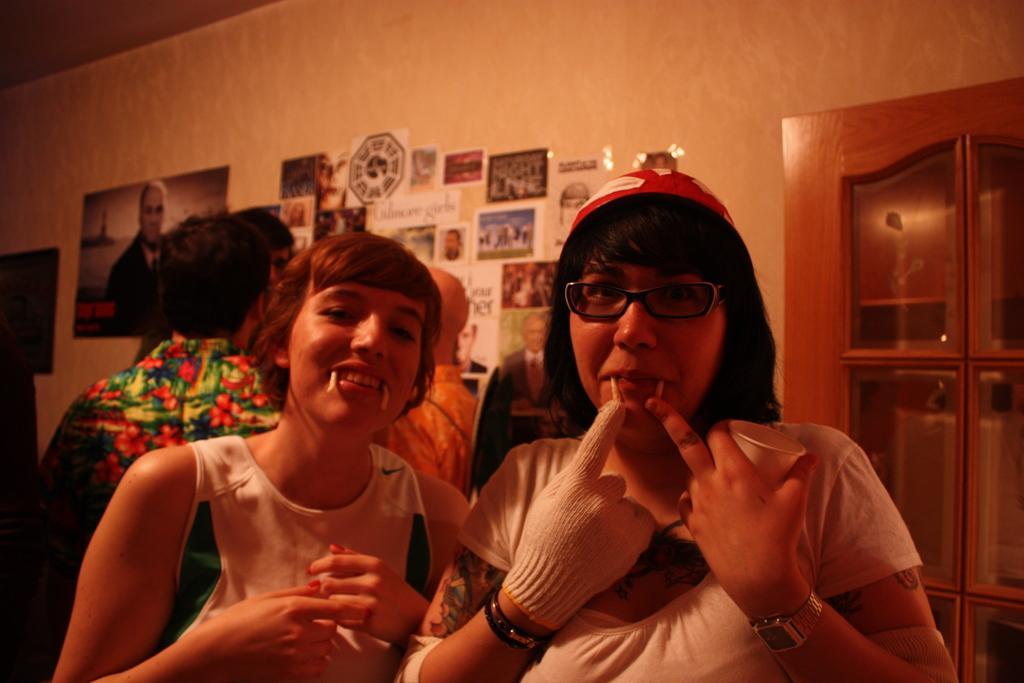Describe this image in one or two sentences. In this image in front there are two people. Behind them there are few other people. In the background of the image there is a wall with the posters on it. On the right side of the image there is a wooden cupboard. 